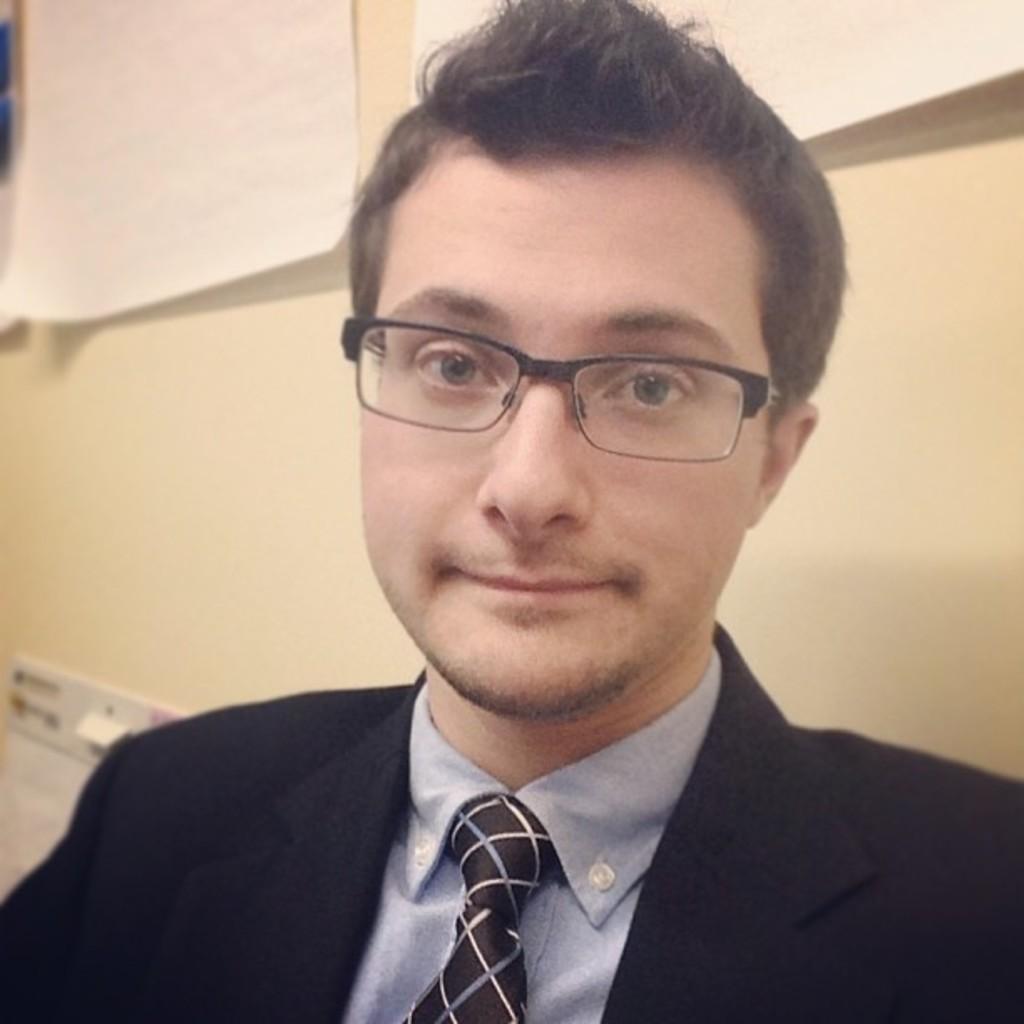In one or two sentences, can you explain what this image depicts? In the image in the center we can see one person. In the background there is a wall,switch board and papers. 